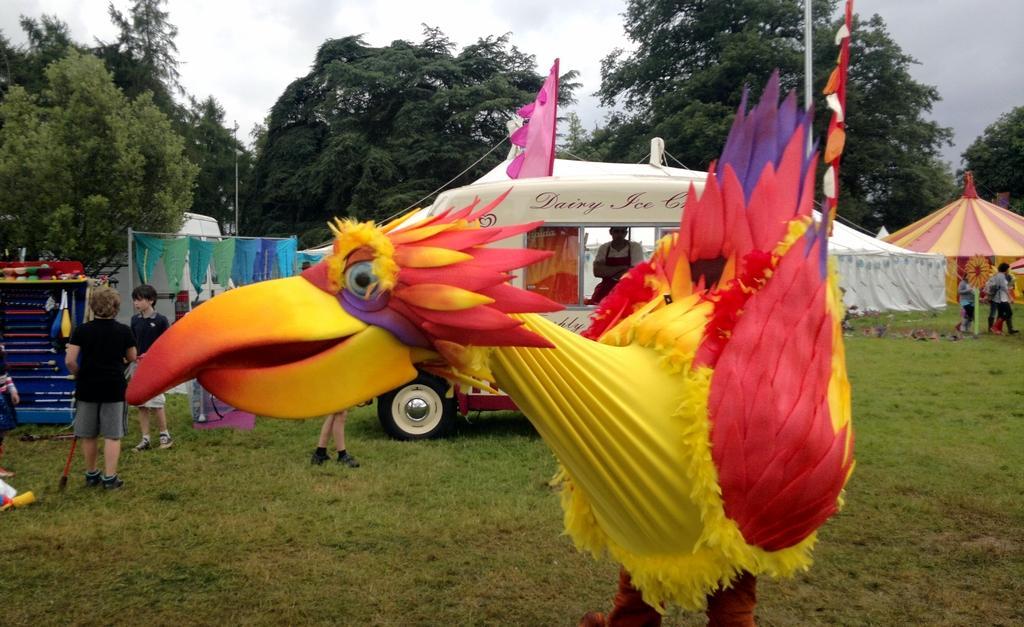Could you give a brief overview of what you see in this image? In this image, we can see green grass on the ground, there is a fun statue, there are some people standing, there are some tents and there are some green color trees, at the top there is a white color sky. 